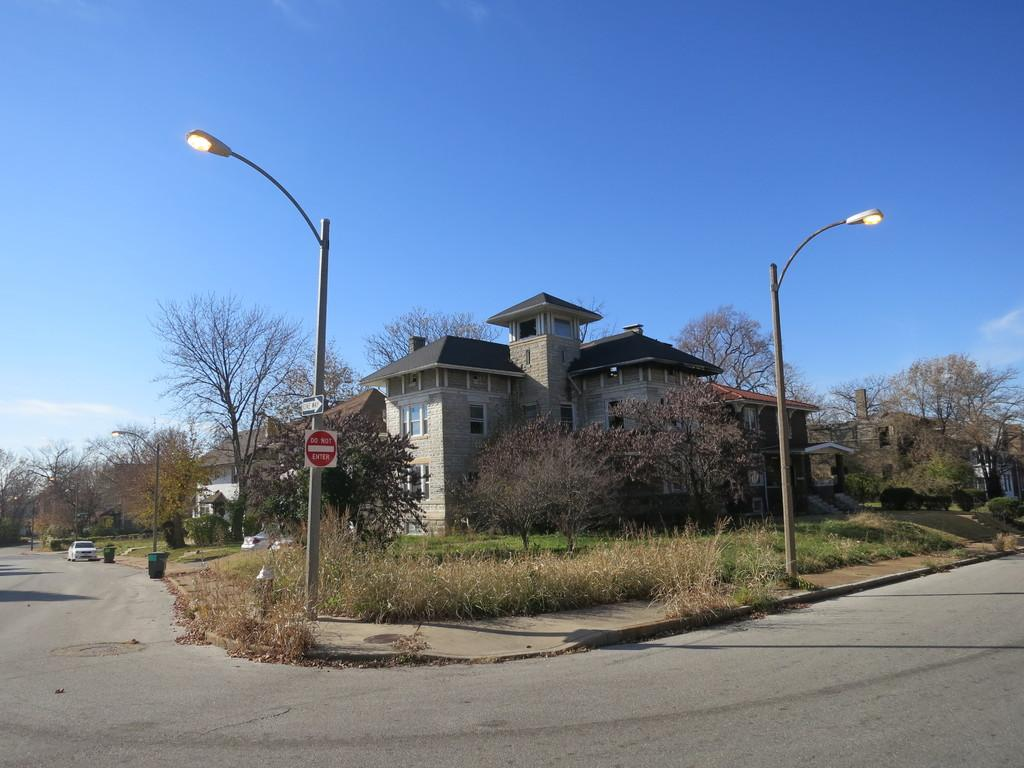Provide a one-sentence caption for the provided image. A sign on a light pole that says Do Not Enter. 